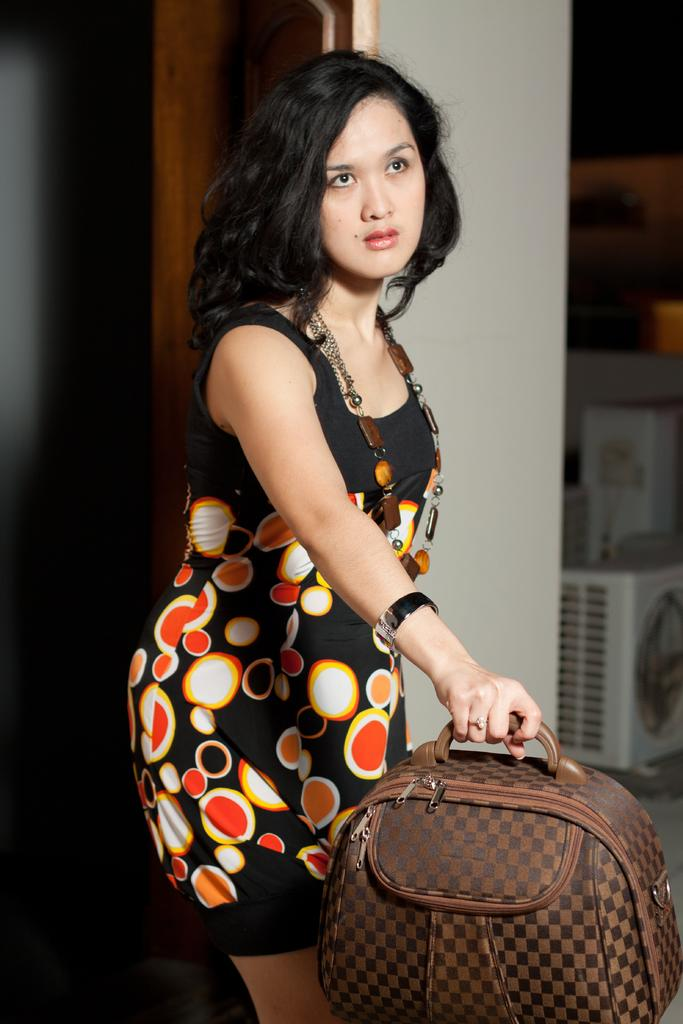Who is present in the image? There is a woman in the image. What is the woman doing in the image? The woman is standing on the floor. What is the woman holding in the image? The woman is holding a handbag. What can be seen in the background of the image? There is a wall in the background of the image. What architectural feature is present in the image? There is a door in the image. How does the woman sort the stranger in the image? There is no stranger present in the image, so the woman cannot sort anyone. 